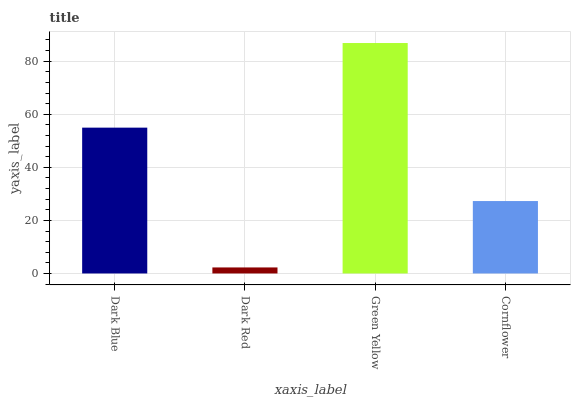Is Dark Red the minimum?
Answer yes or no. Yes. Is Green Yellow the maximum?
Answer yes or no. Yes. Is Green Yellow the minimum?
Answer yes or no. No. Is Dark Red the maximum?
Answer yes or no. No. Is Green Yellow greater than Dark Red?
Answer yes or no. Yes. Is Dark Red less than Green Yellow?
Answer yes or no. Yes. Is Dark Red greater than Green Yellow?
Answer yes or no. No. Is Green Yellow less than Dark Red?
Answer yes or no. No. Is Dark Blue the high median?
Answer yes or no. Yes. Is Cornflower the low median?
Answer yes or no. Yes. Is Green Yellow the high median?
Answer yes or no. No. Is Green Yellow the low median?
Answer yes or no. No. 